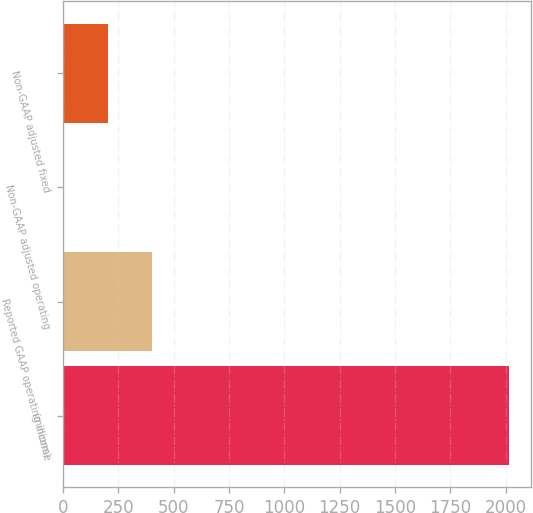Convert chart to OTSL. <chart><loc_0><loc_0><loc_500><loc_500><bar_chart><fcel>(millions)<fcel>Reported GAAP operating income<fcel>Non-GAAP adjusted operating<fcel>Non-GAAP adjusted fixed<nl><fcel>2015<fcel>403.8<fcel>1<fcel>202.4<nl></chart> 